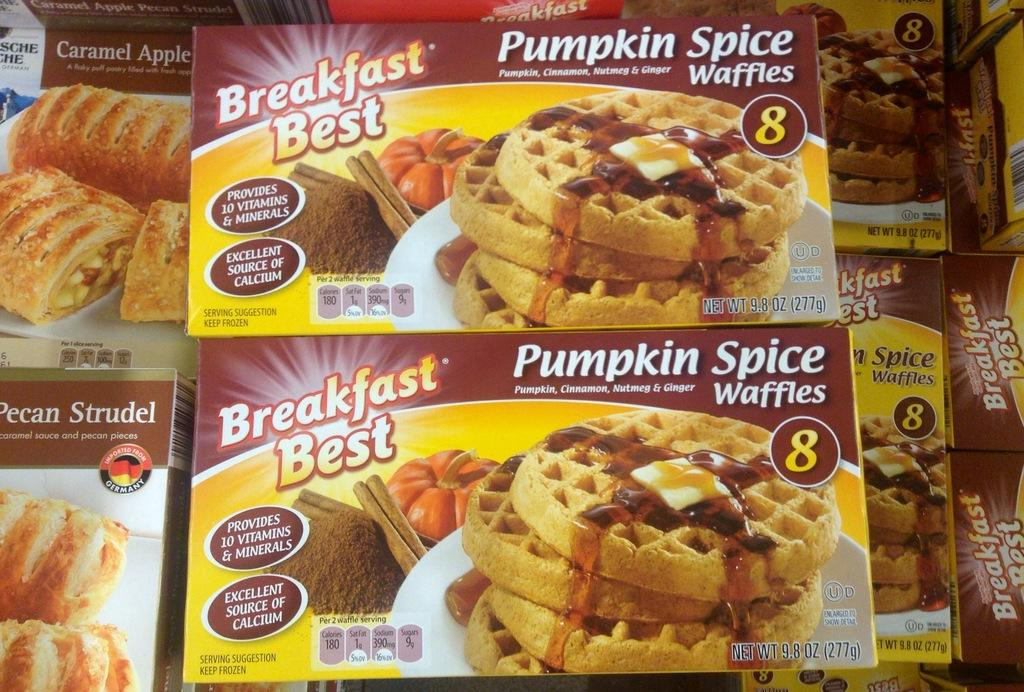What objects are present in the image? There are boxes in the image. What can be seen on the surface of the boxes? The boxes have images of food items on them. Is there any text present on the boxes? Yes, there is text written on the boxes. What type of tin can be seen in the image? There is no tin present in the image; it features boxes with images of food items and text. 